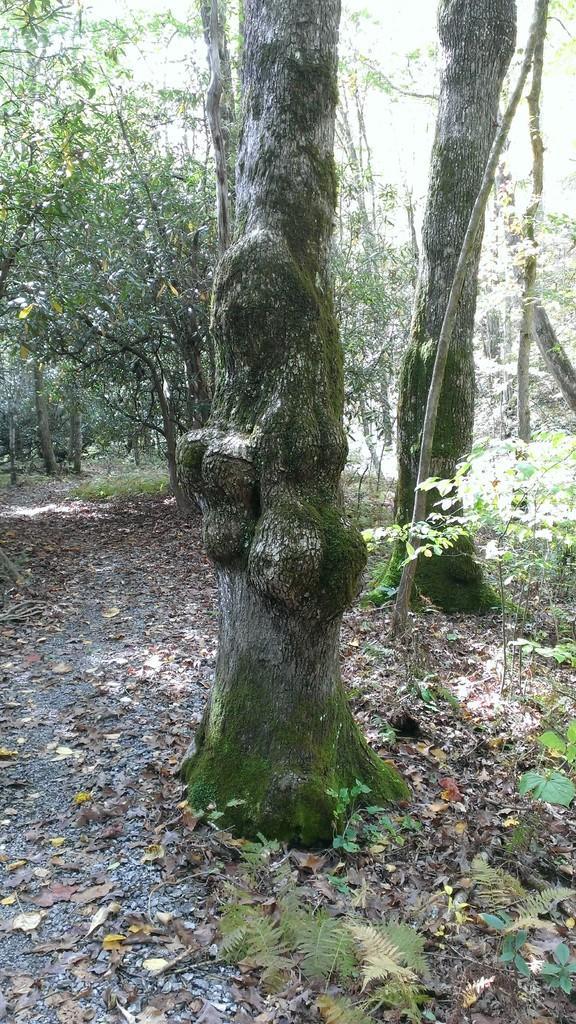Describe this image in one or two sentences. In this picture we can see some trees, at the bottom there are some leaves. 